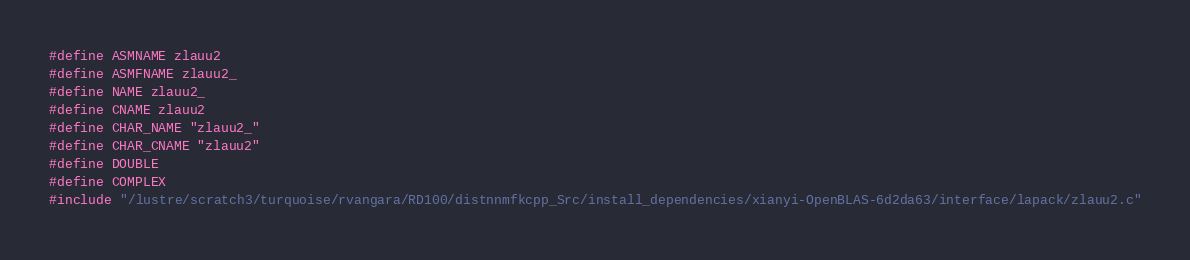<code> <loc_0><loc_0><loc_500><loc_500><_C_>#define ASMNAME zlauu2
#define ASMFNAME zlauu2_
#define NAME zlauu2_
#define CNAME zlauu2
#define CHAR_NAME "zlauu2_"
#define CHAR_CNAME "zlauu2"
#define DOUBLE
#define COMPLEX
#include "/lustre/scratch3/turquoise/rvangara/RD100/distnnmfkcpp_Src/install_dependencies/xianyi-OpenBLAS-6d2da63/interface/lapack/zlauu2.c"</code> 